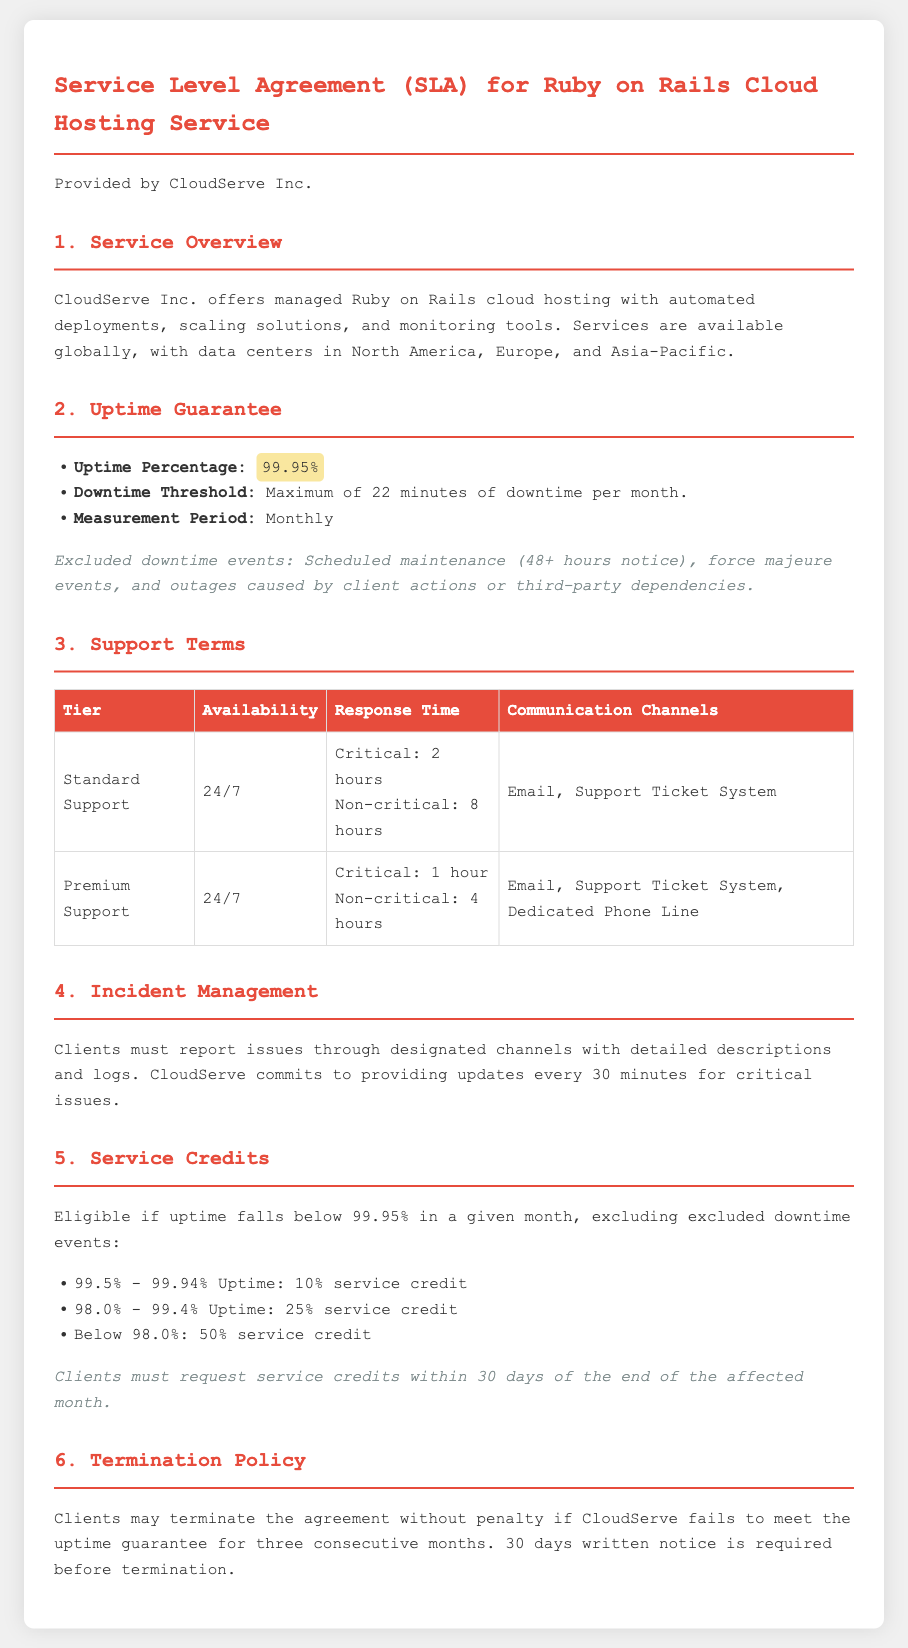what is the uptime percentage guaranteed by CloudServe? The document states that the uptime percentage guaranteed by CloudServe is highlighted in the Uptime Guarantee section.
Answer: 99.95% what is the maximum downtime allowed per month? The document specifies the downtime threshold in the Uptime Guarantee section.
Answer: 22 minutes how often should clients report issues? The Incident Management section mentions the necessity of reporting issues, but it does not specify frequency. The context implies as needed.
Answer: As needed what is the response time for critical issues under Premium Support? The response time for critical issues is listed in the Support Terms section under Premium Support.
Answer: 1 hour what is the percentage of service credit for uptime between 99.5% and 99.94%? The document provides the service credit percentages in the Service Credits section.
Answer: 10% what must clients provide when reporting an issue? The document states that detailed descriptions and logs must be provided in the Incident Management section.
Answer: Detailed descriptions and logs how many hours notice is required for scheduled maintenance? The note under Uptime Guarantee clarifies the notice needed for scheduled maintenance events.
Answer: 48+ hours what happens if CloudServe fails to meet uptime guarantees for three consecutive months? The Termination Policy section outlines the consequences concerning uptime guarantees.
Answer: Termination without penalty which communication channels are available under Standard Support? The communication channels for Standard Support are detailed in the Support Terms table.
Answer: Email, Support Ticket System 